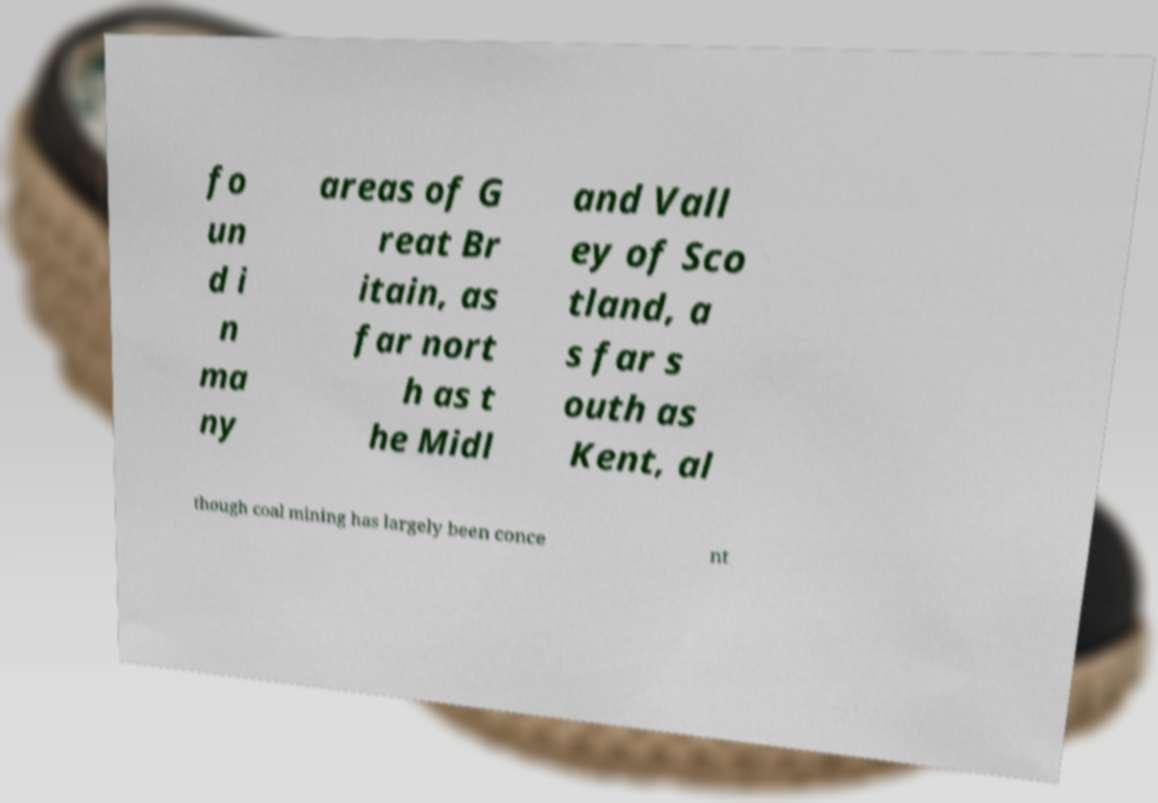There's text embedded in this image that I need extracted. Can you transcribe it verbatim? fo un d i n ma ny areas of G reat Br itain, as far nort h as t he Midl and Vall ey of Sco tland, a s far s outh as Kent, al though coal mining has largely been conce nt 